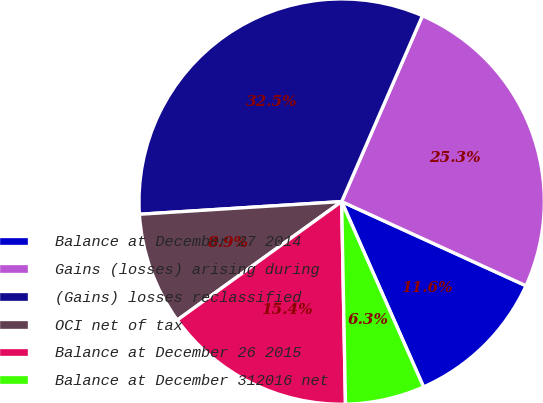<chart> <loc_0><loc_0><loc_500><loc_500><pie_chart><fcel>Balance at December 27 2014<fcel>Gains (losses) arising during<fcel>(Gains) losses reclassified<fcel>OCI net of tax<fcel>Balance at December 26 2015<fcel>Balance at December 312016 net<nl><fcel>11.56%<fcel>25.29%<fcel>32.52%<fcel>8.94%<fcel>15.36%<fcel>6.32%<nl></chart> 